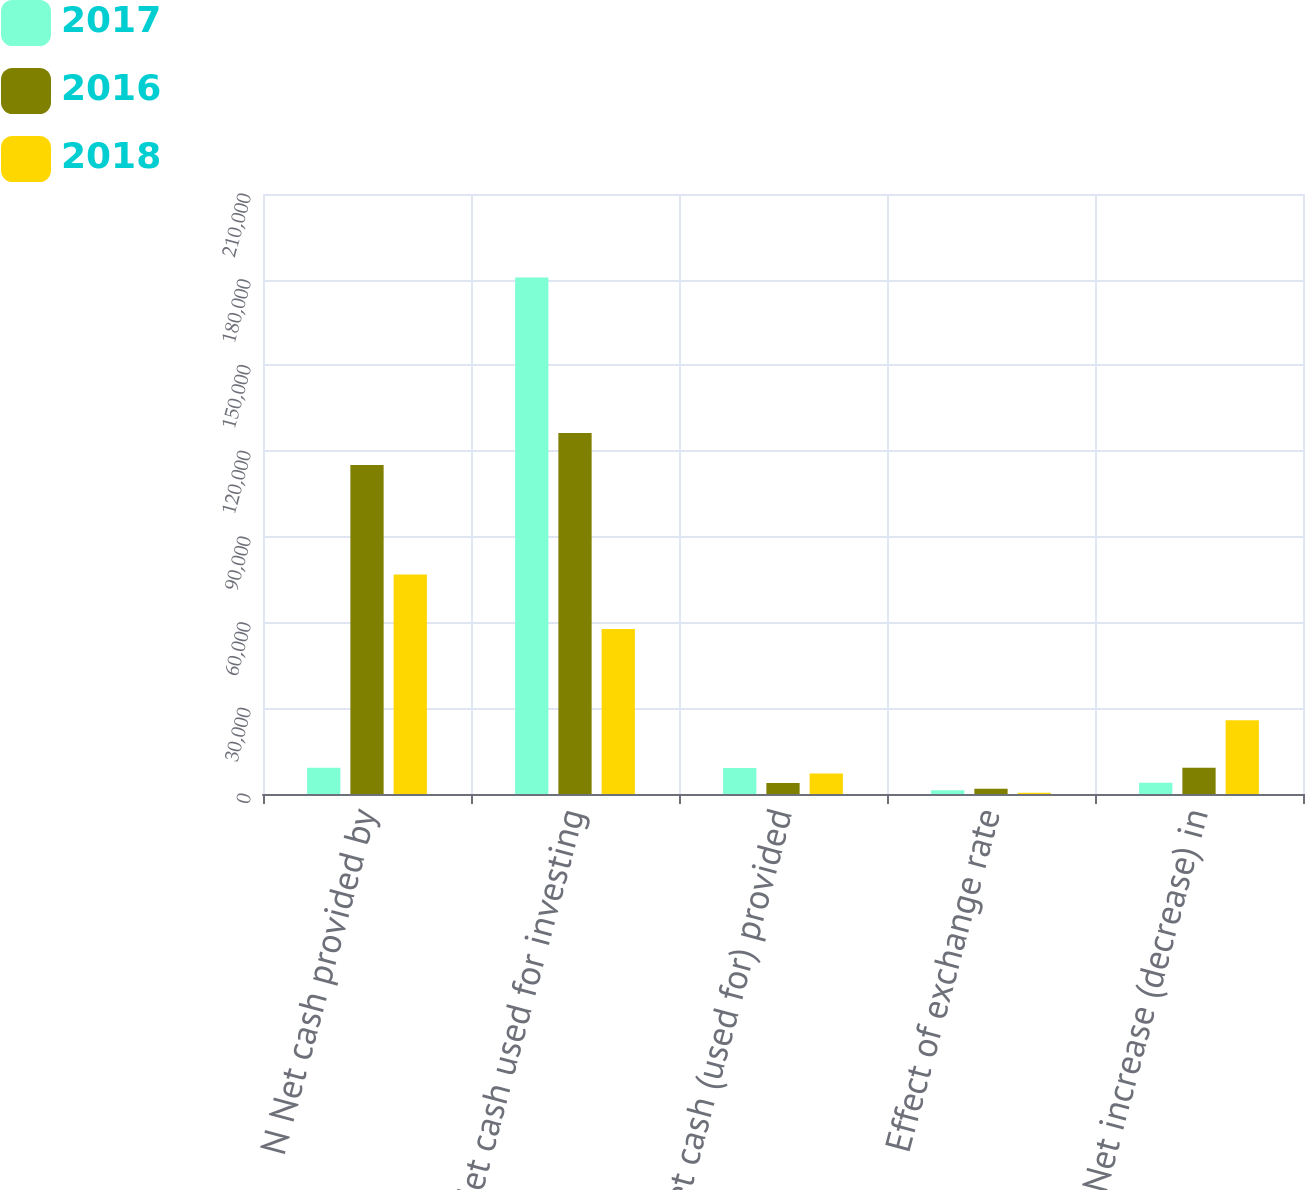Convert chart. <chart><loc_0><loc_0><loc_500><loc_500><stacked_bar_chart><ecel><fcel>N Net cash provided by<fcel>Net cash used for investing<fcel>N Net cash (used for) provided<fcel>Effect of exchange rate<fcel>N Net increase (decrease) in<nl><fcel>2017<fcel>9164<fcel>180762<fcel>9137<fcel>1288<fcel>3935<nl><fcel>2016<fcel>115116<fcel>126333<fcel>3867<fcel>1841<fcel>9191<nl><fcel>2018<fcel>76795<fcel>57710<fcel>7160<fcel>415<fcel>25830<nl></chart> 